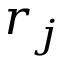<formula> <loc_0><loc_0><loc_500><loc_500>r _ { j }</formula> 